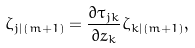Convert formula to latex. <formula><loc_0><loc_0><loc_500><loc_500>\zeta _ { j | ( m + 1 ) } = \frac { \partial \tau _ { j k } } { \partial z _ { k } } \zeta _ { k | ( m + 1 ) } ,</formula> 